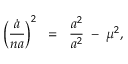Convert formula to latex. <formula><loc_0><loc_0><loc_500><loc_500>\left ( \frac { \dot { a } } { n a } \right ) ^ { 2 } \, = \, \frac { a ^ { 2 } } { a ^ { 2 } } \, - \, \mu ^ { 2 } ,</formula> 